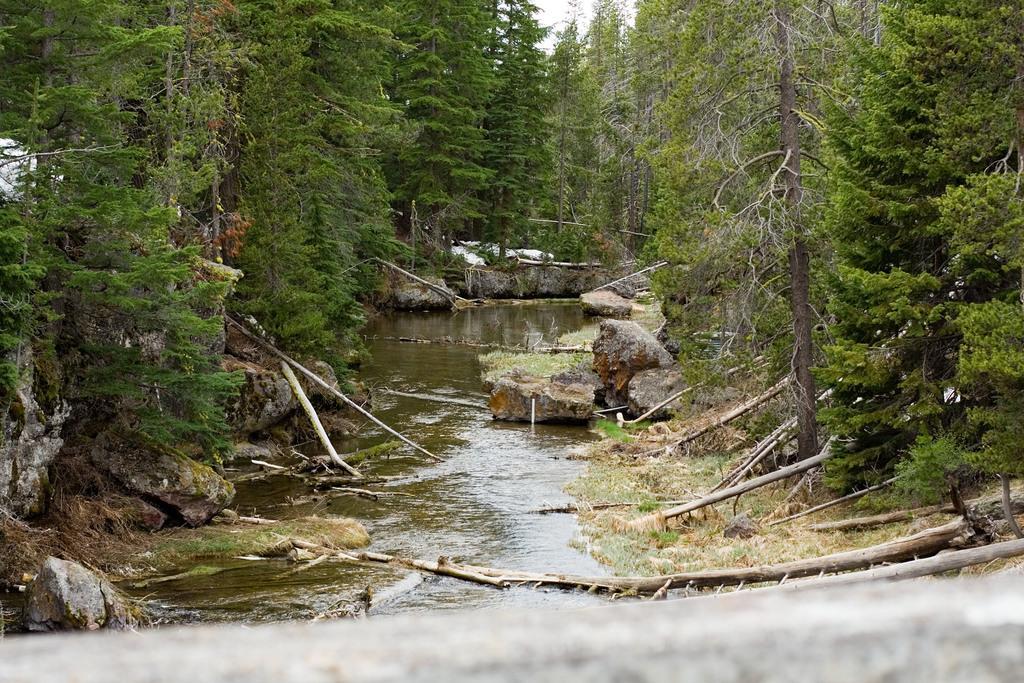Can you describe this image briefly? In the middle it is water, trees. 